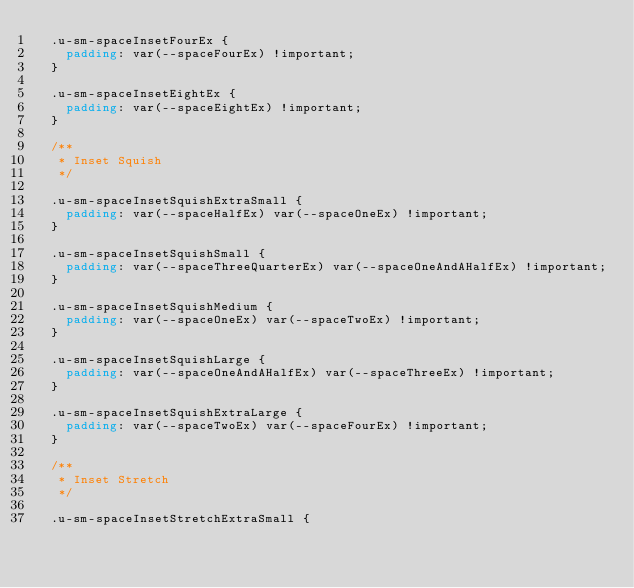<code> <loc_0><loc_0><loc_500><loc_500><_CSS_>  .u-sm-spaceInsetFourEx {
    padding: var(--spaceFourEx) !important;
  }

  .u-sm-spaceInsetEightEx {
    padding: var(--spaceEightEx) !important;
  }

  /**
   * Inset Squish
   */

  .u-sm-spaceInsetSquishExtraSmall {
    padding: var(--spaceHalfEx) var(--spaceOneEx) !important;
  }

  .u-sm-spaceInsetSquishSmall {
    padding: var(--spaceThreeQuarterEx) var(--spaceOneAndAHalfEx) !important;
  }

  .u-sm-spaceInsetSquishMedium {
    padding: var(--spaceOneEx) var(--spaceTwoEx) !important;
  }

  .u-sm-spaceInsetSquishLarge {
    padding: var(--spaceOneAndAHalfEx) var(--spaceThreeEx) !important;
  }

  .u-sm-spaceInsetSquishExtraLarge {
    padding: var(--spaceTwoEx) var(--spaceFourEx) !important;
  }

  /**
   * Inset Stretch
   */

  .u-sm-spaceInsetStretchExtraSmall {</code> 